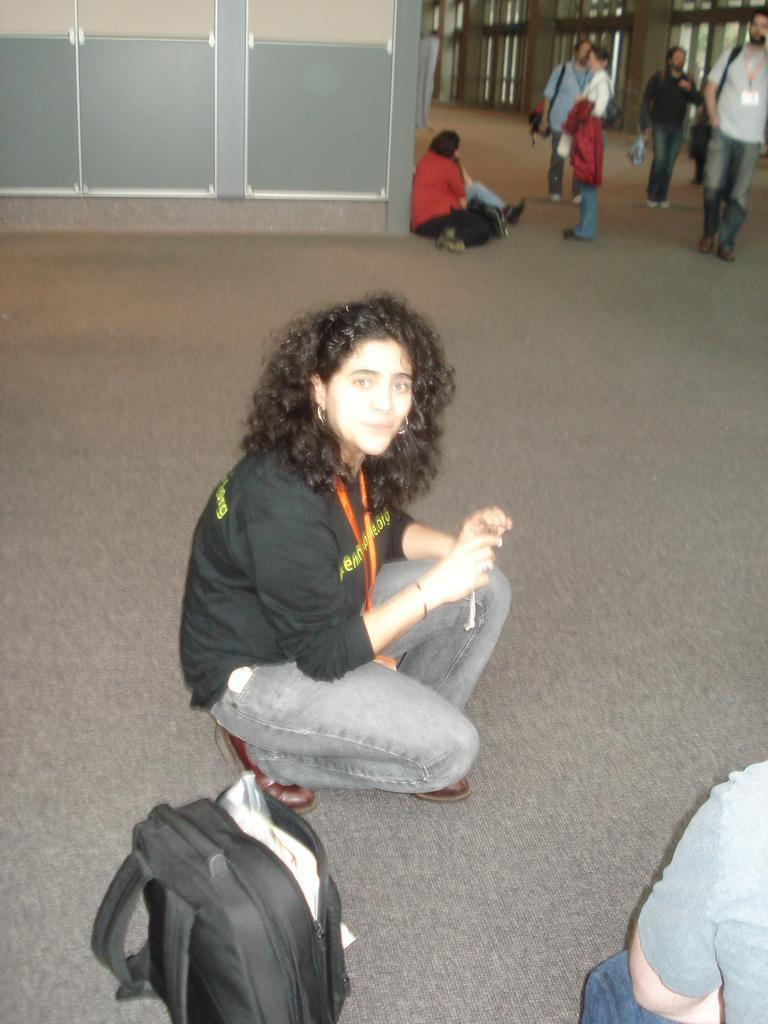How many people are in the image? There is a group of people in the image. What are some of the people doing in the image? Some people are sitting, some are standing, and some are walking. Can you describe the position of the bag in the image? There is a bag at the bottom of the image. What type of basketball game is being observed in the image? There is no basketball game or observation of a game in the image. 